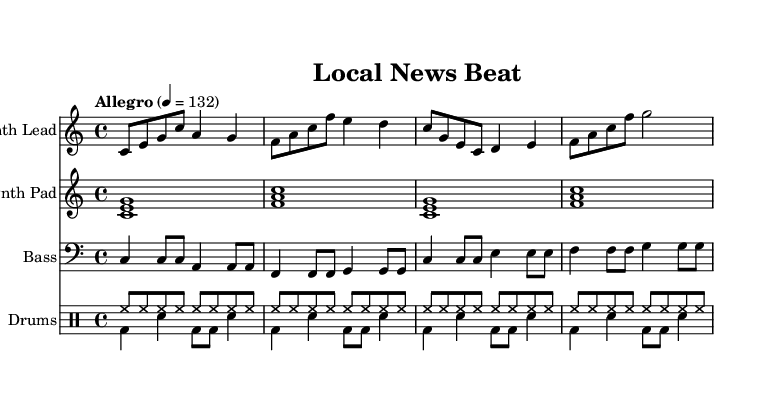What is the key signature of this music? The key signature indicated at the beginning of the music is C major, which has no sharps or flats.
Answer: C major What is the time signature of this piece? The time signature is found at the beginning of the music, displaying 4/4, meaning there are four beats in each measure.
Answer: 4/4 What is the tempo marking for this music? The tempo marking is specified as "Allegro" with a metronome marking of 132 beats per minute. This indicates a fast and lively pace.
Answer: Allegro 4 = 132 How many measures are in the synth lead section? By counting the individual segments in the synth lead part, we see that there are four measures represented in the notation.
Answer: 4 What instrument is used for the bass part? The bass part is written in a bass clef, which indicates it's designed to be played by a bass instrument.
Answer: Bass How many different drum voices are present in the score? The score includes two separate drum voices for the drums, labeled "Voice One" and "Voice Two."
Answer: 2 What type of synthesizer sound is represented by the synth pad? The synth pad is depicted as a chord structure and is described simply, typically conveying a rich and atmospheric sound typical of electronic music.
Answer: Synth pad 